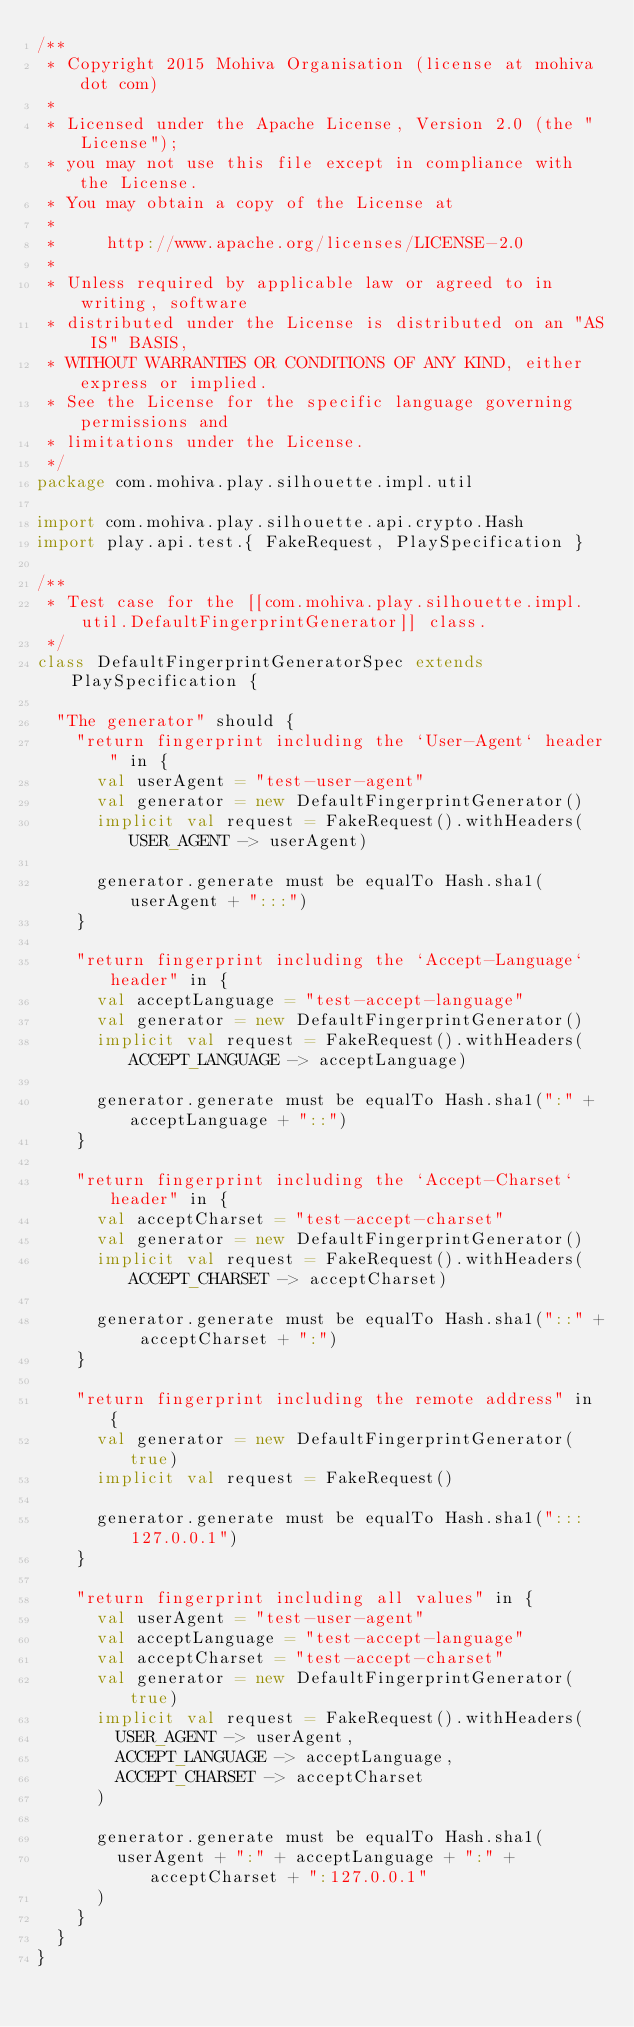<code> <loc_0><loc_0><loc_500><loc_500><_Scala_>/**
 * Copyright 2015 Mohiva Organisation (license at mohiva dot com)
 *
 * Licensed under the Apache License, Version 2.0 (the "License");
 * you may not use this file except in compliance with the License.
 * You may obtain a copy of the License at
 *
 *     http://www.apache.org/licenses/LICENSE-2.0
 *
 * Unless required by applicable law or agreed to in writing, software
 * distributed under the License is distributed on an "AS IS" BASIS,
 * WITHOUT WARRANTIES OR CONDITIONS OF ANY KIND, either express or implied.
 * See the License for the specific language governing permissions and
 * limitations under the License.
 */
package com.mohiva.play.silhouette.impl.util

import com.mohiva.play.silhouette.api.crypto.Hash
import play.api.test.{ FakeRequest, PlaySpecification }

/**
 * Test case for the [[com.mohiva.play.silhouette.impl.util.DefaultFingerprintGenerator]] class.
 */
class DefaultFingerprintGeneratorSpec extends PlaySpecification {

  "The generator" should {
    "return fingerprint including the `User-Agent` header" in {
      val userAgent = "test-user-agent"
      val generator = new DefaultFingerprintGenerator()
      implicit val request = FakeRequest().withHeaders(USER_AGENT -> userAgent)

      generator.generate must be equalTo Hash.sha1(userAgent + ":::")
    }

    "return fingerprint including the `Accept-Language` header" in {
      val acceptLanguage = "test-accept-language"
      val generator = new DefaultFingerprintGenerator()
      implicit val request = FakeRequest().withHeaders(ACCEPT_LANGUAGE -> acceptLanguage)

      generator.generate must be equalTo Hash.sha1(":" + acceptLanguage + "::")
    }

    "return fingerprint including the `Accept-Charset` header" in {
      val acceptCharset = "test-accept-charset"
      val generator = new DefaultFingerprintGenerator()
      implicit val request = FakeRequest().withHeaders(ACCEPT_CHARSET -> acceptCharset)

      generator.generate must be equalTo Hash.sha1("::" + acceptCharset + ":")
    }

    "return fingerprint including the remote address" in {
      val generator = new DefaultFingerprintGenerator(true)
      implicit val request = FakeRequest()

      generator.generate must be equalTo Hash.sha1(":::127.0.0.1")
    }

    "return fingerprint including all values" in {
      val userAgent = "test-user-agent"
      val acceptLanguage = "test-accept-language"
      val acceptCharset = "test-accept-charset"
      val generator = new DefaultFingerprintGenerator(true)
      implicit val request = FakeRequest().withHeaders(
        USER_AGENT -> userAgent,
        ACCEPT_LANGUAGE -> acceptLanguage,
        ACCEPT_CHARSET -> acceptCharset
      )

      generator.generate must be equalTo Hash.sha1(
        userAgent + ":" + acceptLanguage + ":" + acceptCharset + ":127.0.0.1"
      )
    }
  }
}
</code> 